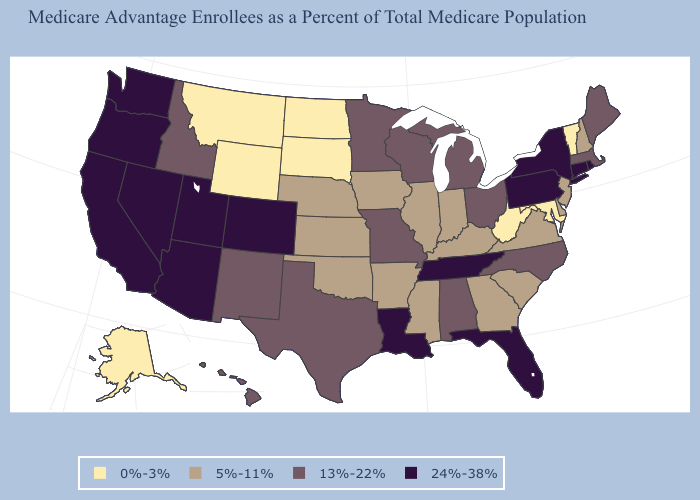Which states have the lowest value in the West?
Write a very short answer. Alaska, Montana, Wyoming. What is the highest value in the MidWest ?
Keep it brief. 13%-22%. What is the value of Mississippi?
Be succinct. 5%-11%. Name the states that have a value in the range 13%-22%?
Answer briefly. Alabama, Hawaii, Idaho, Massachusetts, Maine, Michigan, Minnesota, Missouri, North Carolina, New Mexico, Ohio, Texas, Wisconsin. Does Indiana have a lower value than Vermont?
Keep it brief. No. What is the lowest value in states that border Idaho?
Answer briefly. 0%-3%. Which states have the highest value in the USA?
Give a very brief answer. Arizona, California, Colorado, Connecticut, Florida, Louisiana, Nevada, New York, Oregon, Pennsylvania, Rhode Island, Tennessee, Utah, Washington. Does Wisconsin have a lower value than Rhode Island?
Concise answer only. Yes. Does Rhode Island have the highest value in the Northeast?
Answer briefly. Yes. Does New York have the highest value in the Northeast?
Short answer required. Yes. Is the legend a continuous bar?
Write a very short answer. No. Name the states that have a value in the range 5%-11%?
Keep it brief. Arkansas, Delaware, Georgia, Iowa, Illinois, Indiana, Kansas, Kentucky, Mississippi, Nebraska, New Hampshire, New Jersey, Oklahoma, South Carolina, Virginia. What is the lowest value in states that border Michigan?
Answer briefly. 5%-11%. What is the lowest value in the USA?
Give a very brief answer. 0%-3%. Does New Mexico have the highest value in the USA?
Answer briefly. No. 